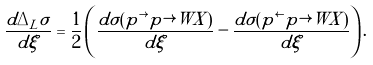<formula> <loc_0><loc_0><loc_500><loc_500>\frac { d \Delta _ { L } \sigma } { d \xi } = \frac { 1 } { 2 } \left ( \frac { d \sigma ( p ^ { \rightarrow } p \rightarrow W X ) } { d \xi } - \frac { d \sigma ( p ^ { \leftarrow } p \rightarrow W X ) } { d \xi } \right ) .</formula> 